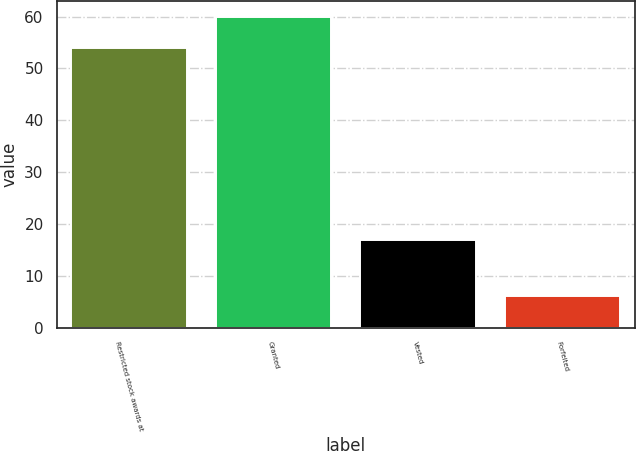Convert chart. <chart><loc_0><loc_0><loc_500><loc_500><bar_chart><fcel>Restricted stock awards at<fcel>Granted<fcel>Vested<fcel>Forfeited<nl><fcel>54<fcel>60<fcel>16.8<fcel>6<nl></chart> 